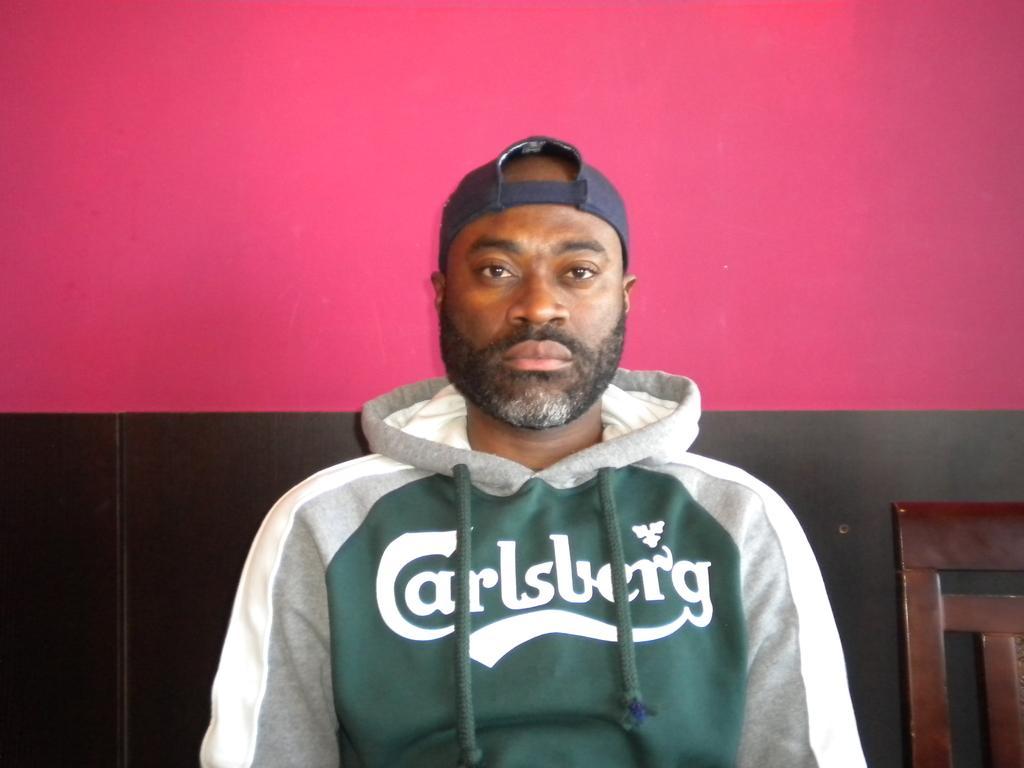Please provide a concise description of this image. In the image there is a man with a cap on his head. Behind him there is a wall which is in pink and black color. In the bottom right corner of the image there is a chair. 